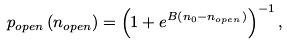<formula> <loc_0><loc_0><loc_500><loc_500>p _ { o p e n } \left ( n _ { o p e n } \right ) = \left ( 1 + e ^ { B \left ( n _ { 0 } - n _ { o p e n } \right ) } \right ) ^ { - 1 } ,</formula> 